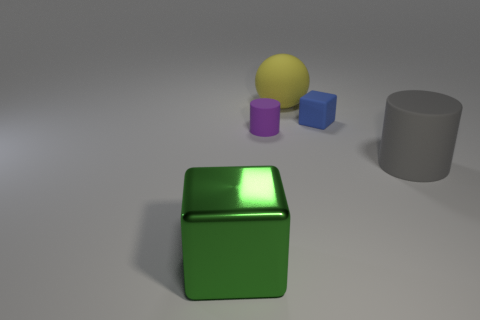Add 2 small rubber blocks. How many objects exist? 7 Subtract all cylinders. How many objects are left? 3 Add 3 tiny brown metal objects. How many tiny brown metal objects exist? 3 Subtract 0 green spheres. How many objects are left? 5 Subtract all big brown things. Subtract all purple things. How many objects are left? 4 Add 5 gray cylinders. How many gray cylinders are left? 6 